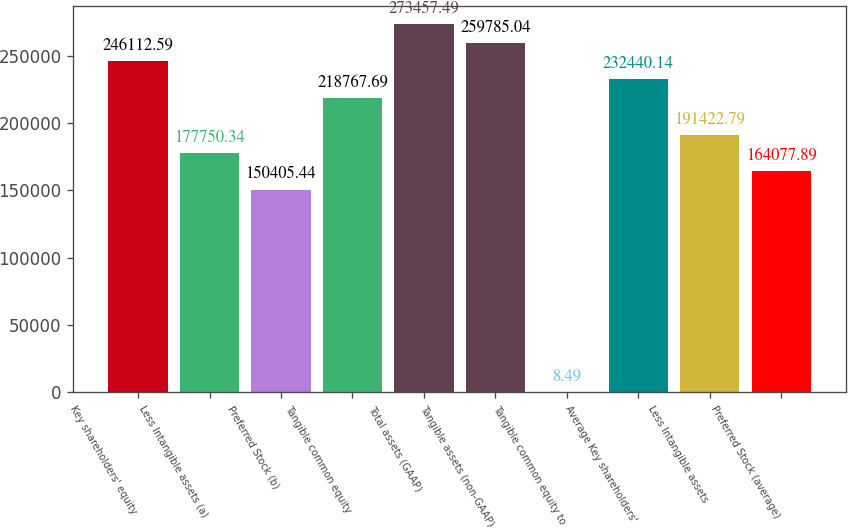Convert chart. <chart><loc_0><loc_0><loc_500><loc_500><bar_chart><fcel>Key shareholders' equity<fcel>Less Intangible assets (a)<fcel>Preferred Stock (b)<fcel>Tangible common equity<fcel>Total assets (GAAP)<fcel>Tangible assets (non-GAAP)<fcel>Tangible common equity to<fcel>Average Key shareholders'<fcel>Less Intangible assets<fcel>Preferred Stock (average)<nl><fcel>246113<fcel>177750<fcel>150405<fcel>218768<fcel>273457<fcel>259785<fcel>8.49<fcel>232440<fcel>191423<fcel>164078<nl></chart> 